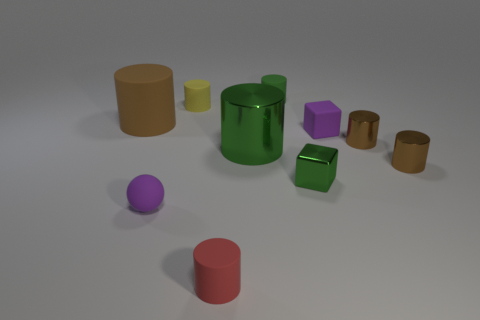Subtract all cyan blocks. How many brown cylinders are left? 3 Subtract all red cylinders. How many cylinders are left? 6 Subtract all green metal cylinders. How many cylinders are left? 6 Subtract all gray cylinders. Subtract all red spheres. How many cylinders are left? 7 Subtract all spheres. How many objects are left? 9 Add 6 red cylinders. How many red cylinders exist? 7 Subtract 0 red cubes. How many objects are left? 10 Subtract all red matte objects. Subtract all tiny metallic cylinders. How many objects are left? 7 Add 7 green metal objects. How many green metal objects are left? 9 